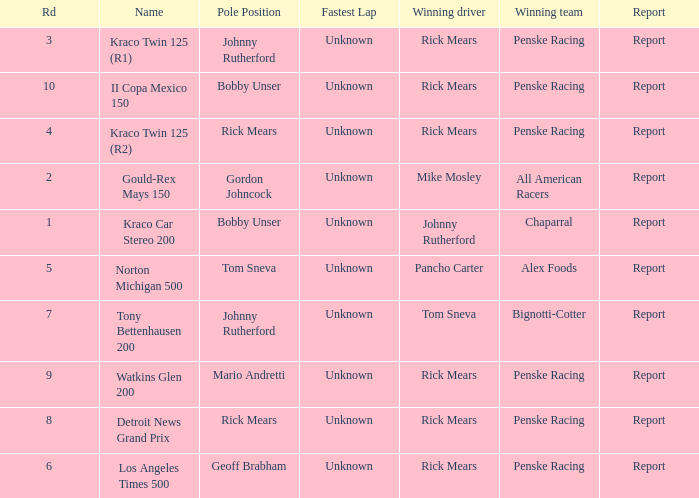The race tony bettenhausen 200 has what smallest rd? 7.0. 